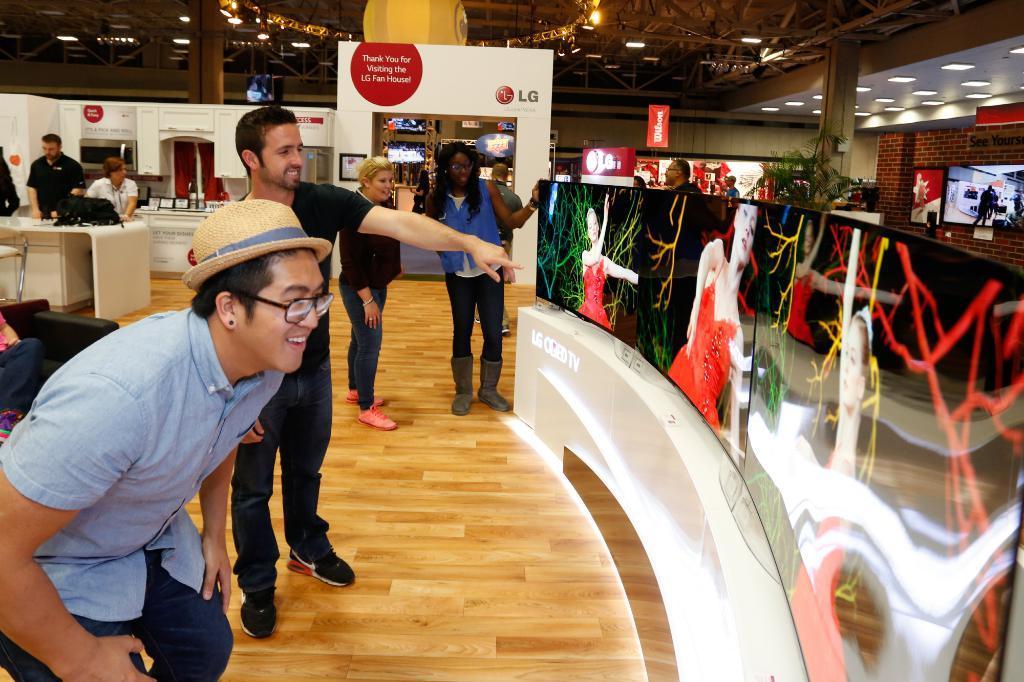Describe this image in one or two sentences. In this picture there is a man with blue shirt is standing and smiling and there are group of people standing. On the right side of the image there are televisions and there is a picture of a woman on the screens. At the back there are boards and there is text on the boards and there is a plant and there are screens. On the left side of the image there are objects on the table. At the top there are lights. At the bottom there is a floor. 